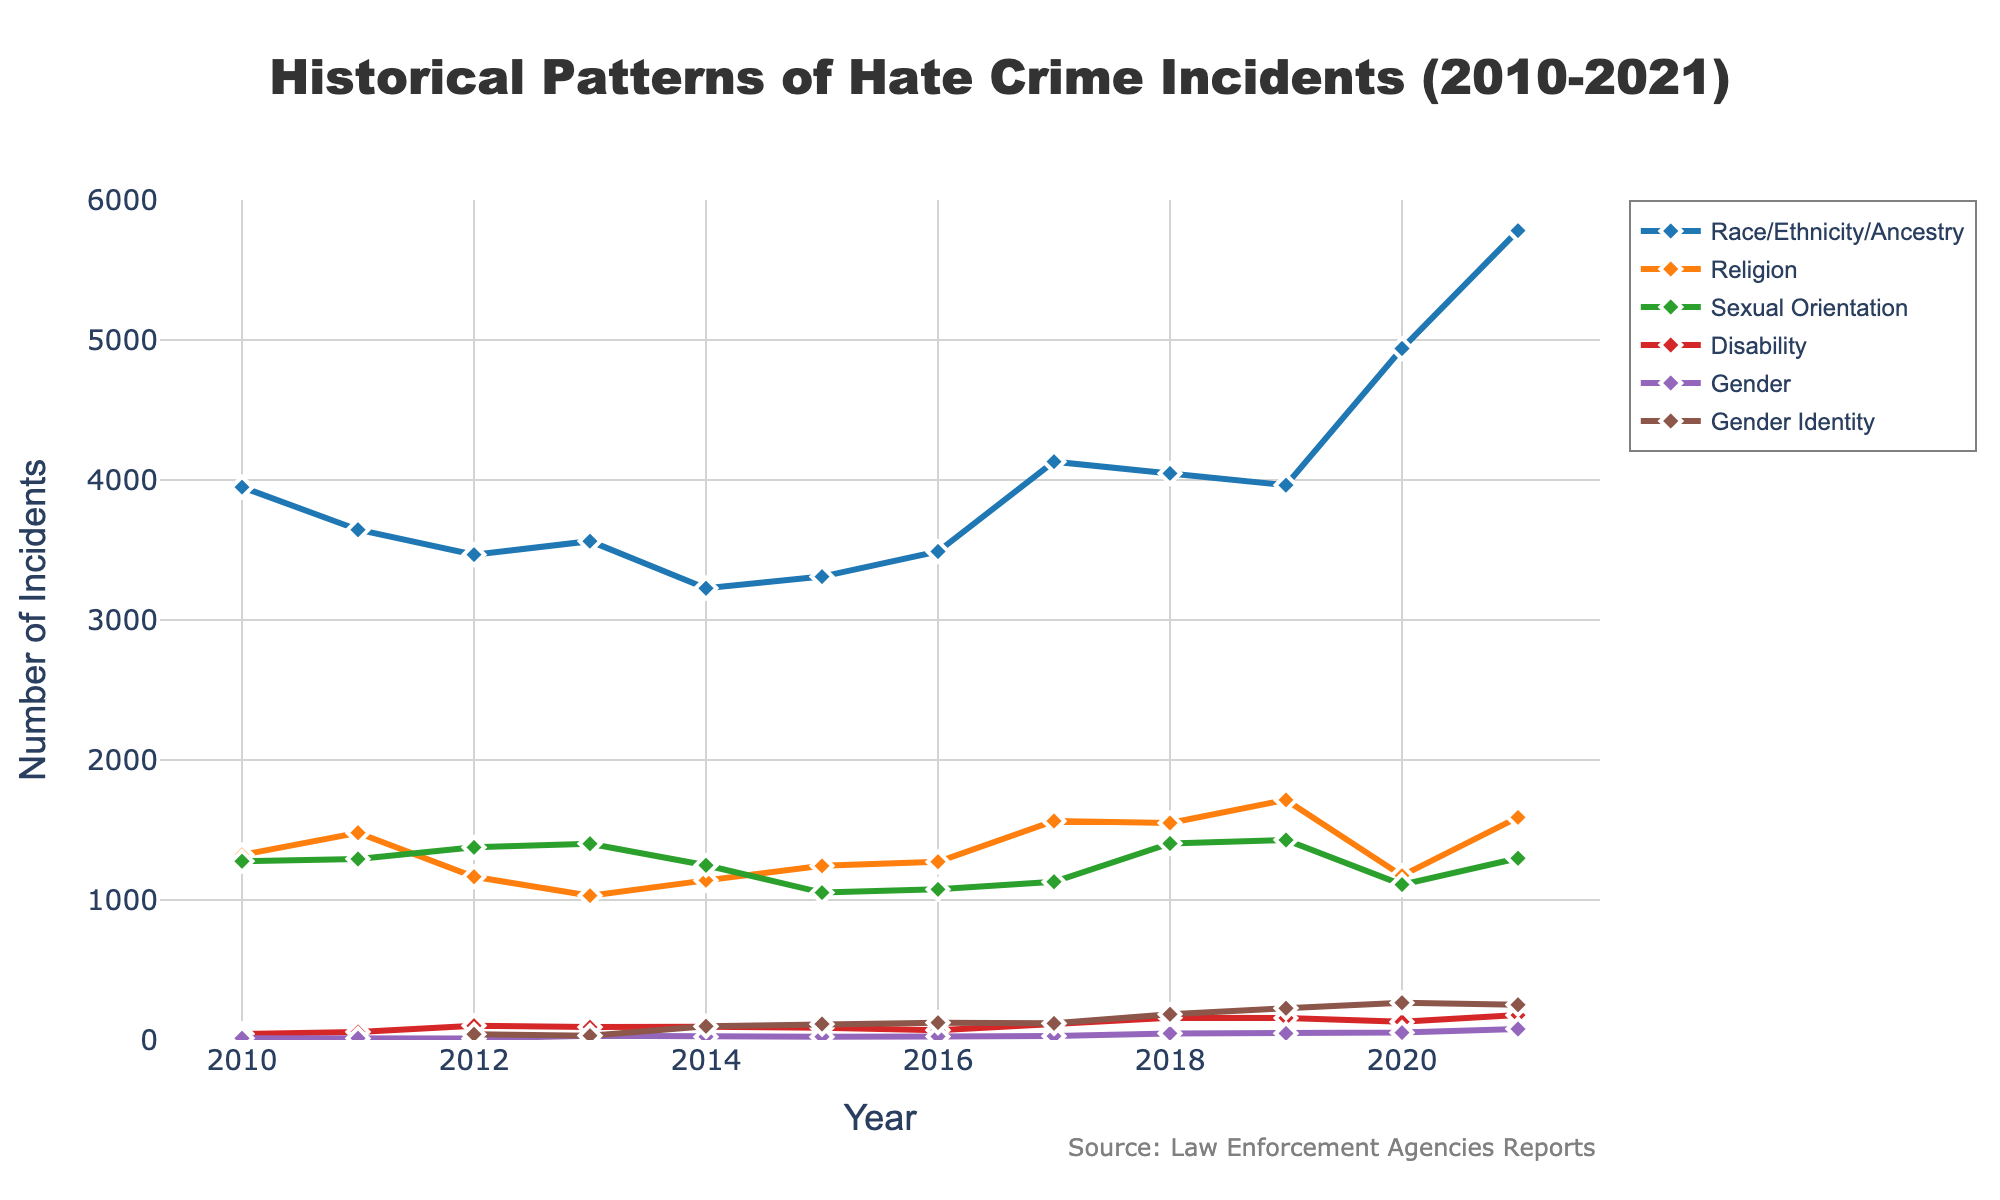What category reached its highest number of incidents in 2021? By looking at the peaks of all the lines and finding the highest point in 2021, we can see that Race/Ethnicity/Ancestry incidents are the most numerous.
Answer: Race/Ethnicity/Ancestry Which category had a noticeable upward trend from 2019 to 2021? By observing the line segments from 2019 to 2021 for each category, we see that Race/Ethnicity/Ancestry and Gender showed upward trends, with Race/Ethnicity/Ancestry being the most significant.
Answer: Race/Ethnicity/Ancestry In what year did Sexual Orientation incidents peak, and what was the value? By following the line representing Sexual Orientation, we notice it peaks in 2019. We then look at the y-axis to find the value.
Answer: 2019, 1429 What is the average number of hate crime incidents reported for Religion from 2010 to 2021? Adding the incidents for each year (1322+1480+1166+1031+1140+1244+1273+1564+1550+1715+1174+1590) and then dividing by the number of years (12) gives 1435.33.
Answer: 1435.33 Which category had the smallest number of incidents in 2011? By comparing the values for each category in 2011, we see Disability had the smallest reported incidents with 58.
Answer: Disability Between which years did the incidents of Gender Identity experience the largest relative increase? By looking at Gender Identity line, the largest jump can be found between 2015 and 2016, from 114 to 124, which is a difference of 10 incidents.
Answer: 2015-2016 Did incidents for any categories show a consistent downward trend from 2010 to 2019? By following each category's line over the years, we see that neither Race/Ethnicity/Ancestry, Religion, Sexual Orientation, Disability, nor Gender shows a consistently downward trend; all exhibit fluctuations rather than steady declines.
Answer: No How many more Race/Ethnicity/Ancestry incidents were there in 2021 compared to 2014? Subtracting the incidents in 2014 from 2021 for Race/Ethnicity/Ancestry (5781 - 3227 = 2554) gives the number of additional incidents.
Answer: 2554 Which category's line is colored green? By matching the colors to their respective lines, Sexual Orientation's line is identified as green.
Answer: Sexual Orientation What is the range of incidents reported for Sexual Orientation throughout the years shown? Finding the maximum value (1429 in 2019) and the minimum value (1053 in 2015) for Sexual Orientation, then subtracting the minimum from the maximum gives the range: 1429 - 1053 = 376.
Answer: 376 